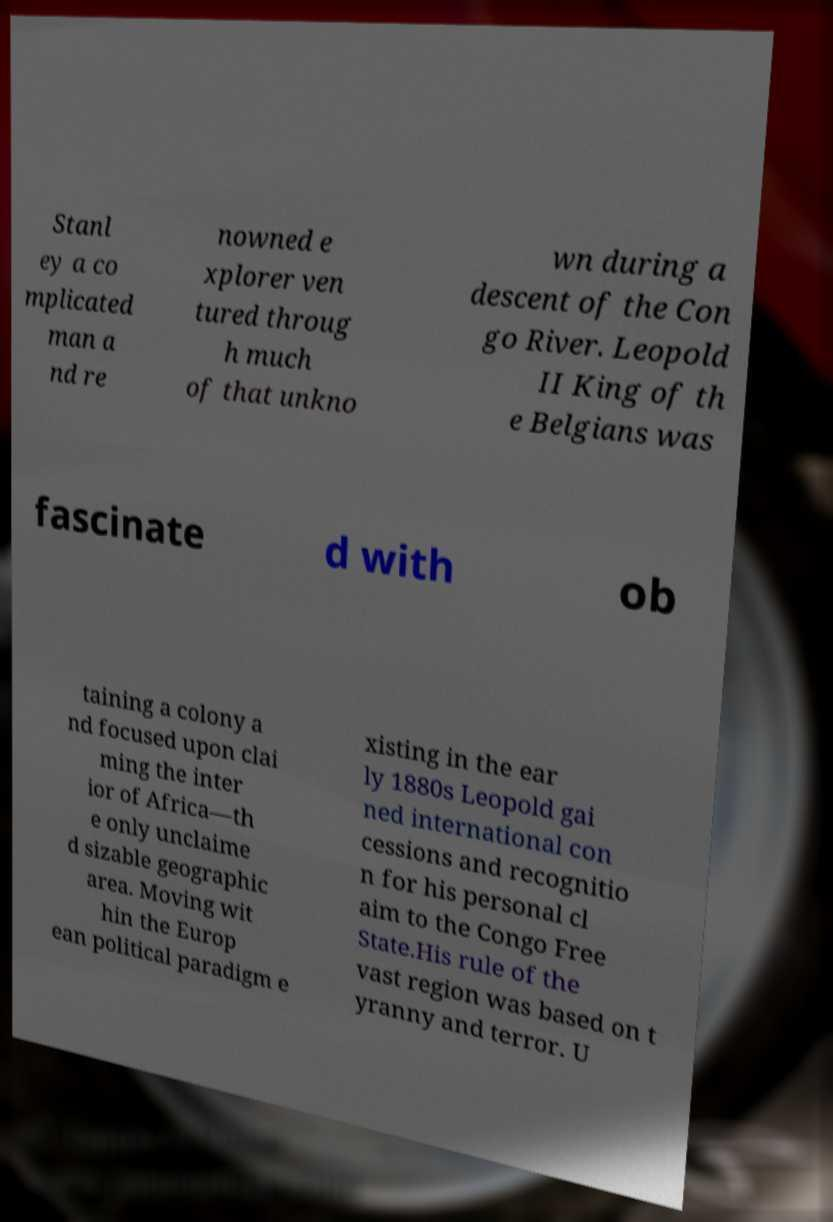Can you accurately transcribe the text from the provided image for me? Stanl ey a co mplicated man a nd re nowned e xplorer ven tured throug h much of that unkno wn during a descent of the Con go River. Leopold II King of th e Belgians was fascinate d with ob taining a colony a nd focused upon clai ming the inter ior of Africa—th e only unclaime d sizable geographic area. Moving wit hin the Europ ean political paradigm e xisting in the ear ly 1880s Leopold gai ned international con cessions and recognitio n for his personal cl aim to the Congo Free State.His rule of the vast region was based on t yranny and terror. U 